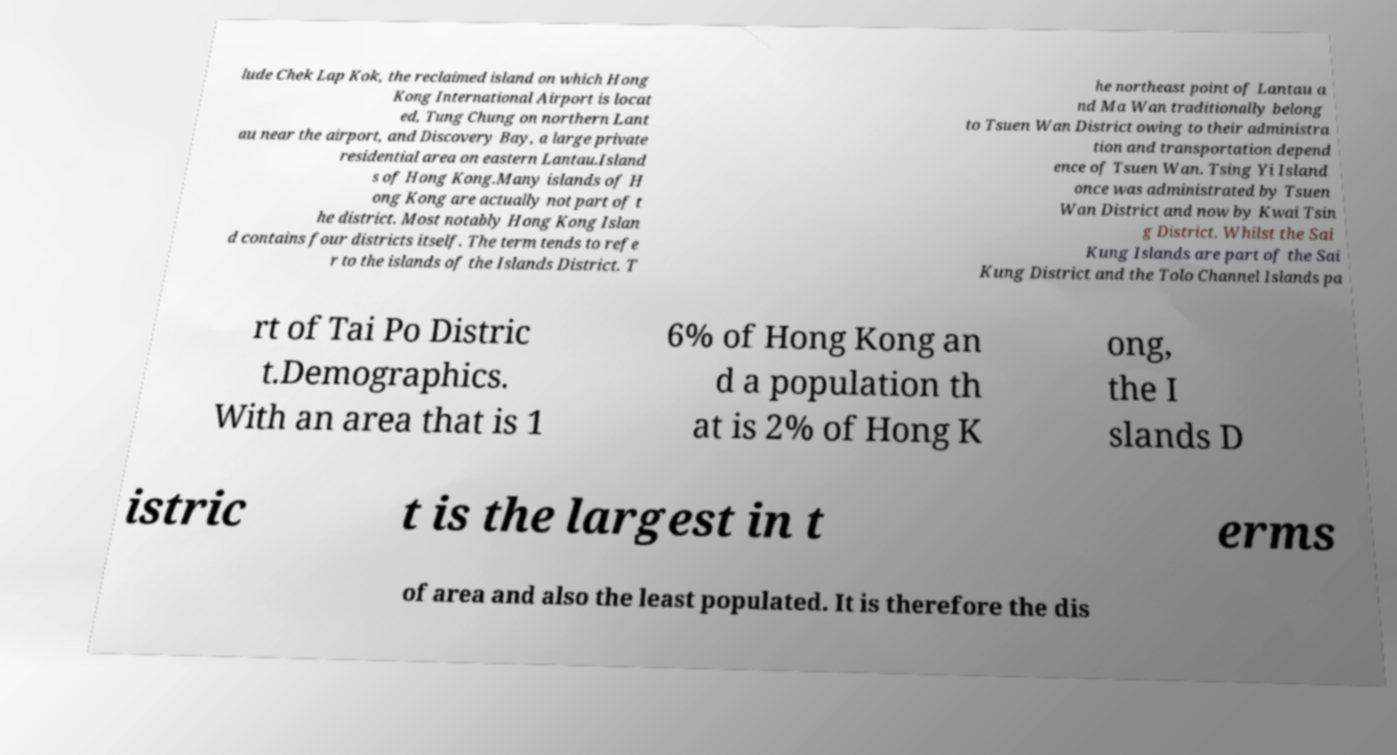There's text embedded in this image that I need extracted. Can you transcribe it verbatim? lude Chek Lap Kok, the reclaimed island on which Hong Kong International Airport is locat ed, Tung Chung on northern Lant au near the airport, and Discovery Bay, a large private residential area on eastern Lantau.Island s of Hong Kong.Many islands of H ong Kong are actually not part of t he district. Most notably Hong Kong Islan d contains four districts itself. The term tends to refe r to the islands of the Islands District. T he northeast point of Lantau a nd Ma Wan traditionally belong to Tsuen Wan District owing to their administra tion and transportation depend ence of Tsuen Wan. Tsing Yi Island once was administrated by Tsuen Wan District and now by Kwai Tsin g District. Whilst the Sai Kung Islands are part of the Sai Kung District and the Tolo Channel Islands pa rt of Tai Po Distric t.Demographics. With an area that is 1 6% of Hong Kong an d a population th at is 2% of Hong K ong, the I slands D istric t is the largest in t erms of area and also the least populated. It is therefore the dis 